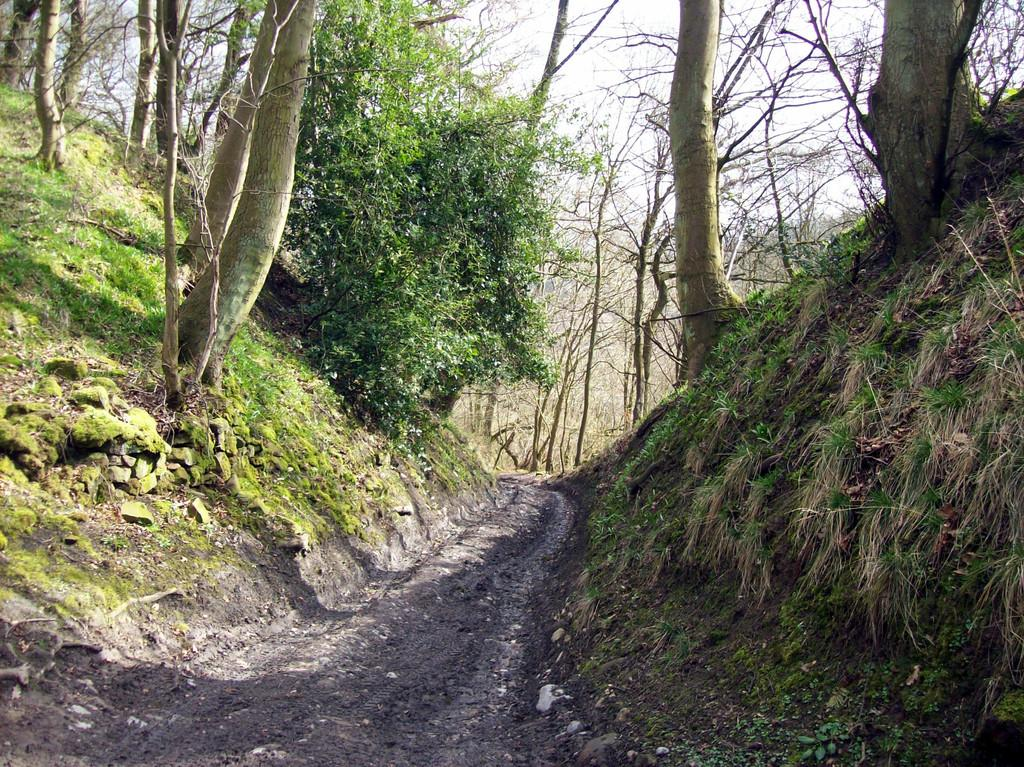What is the main feature of the image? There is a pathway in the image. What can be seen on the left side of the pathway? On the left side of the image, there are plants, tree bark, stones, and grass. What is visible on the right side of the pathway? On the right side of the image, there is dried grass and the sky. What type of approval is required to enter the frame in the image? There is no frame present in the image, and therefore no approval is required to enter it. 